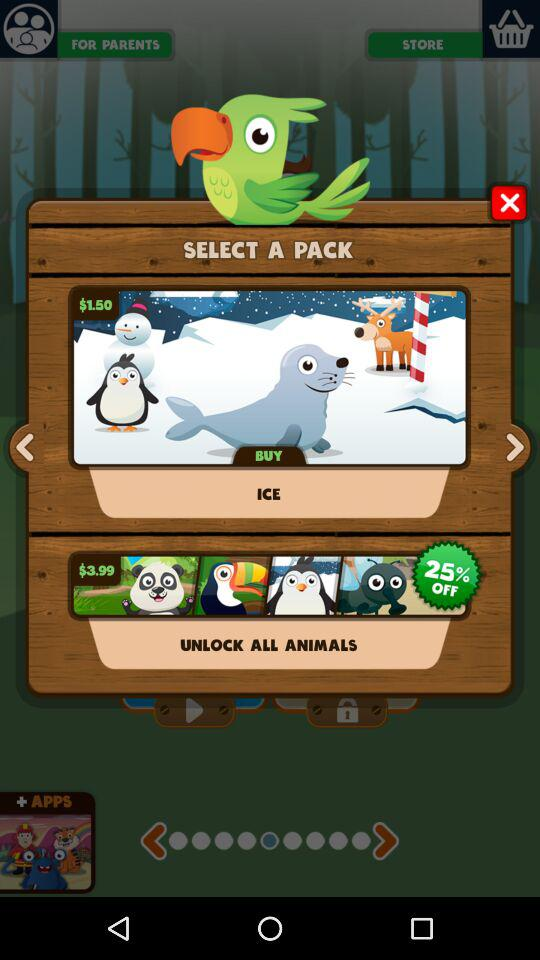What is the price of the "ICE" pack? The price of the "ICE" pack is $1.50. 